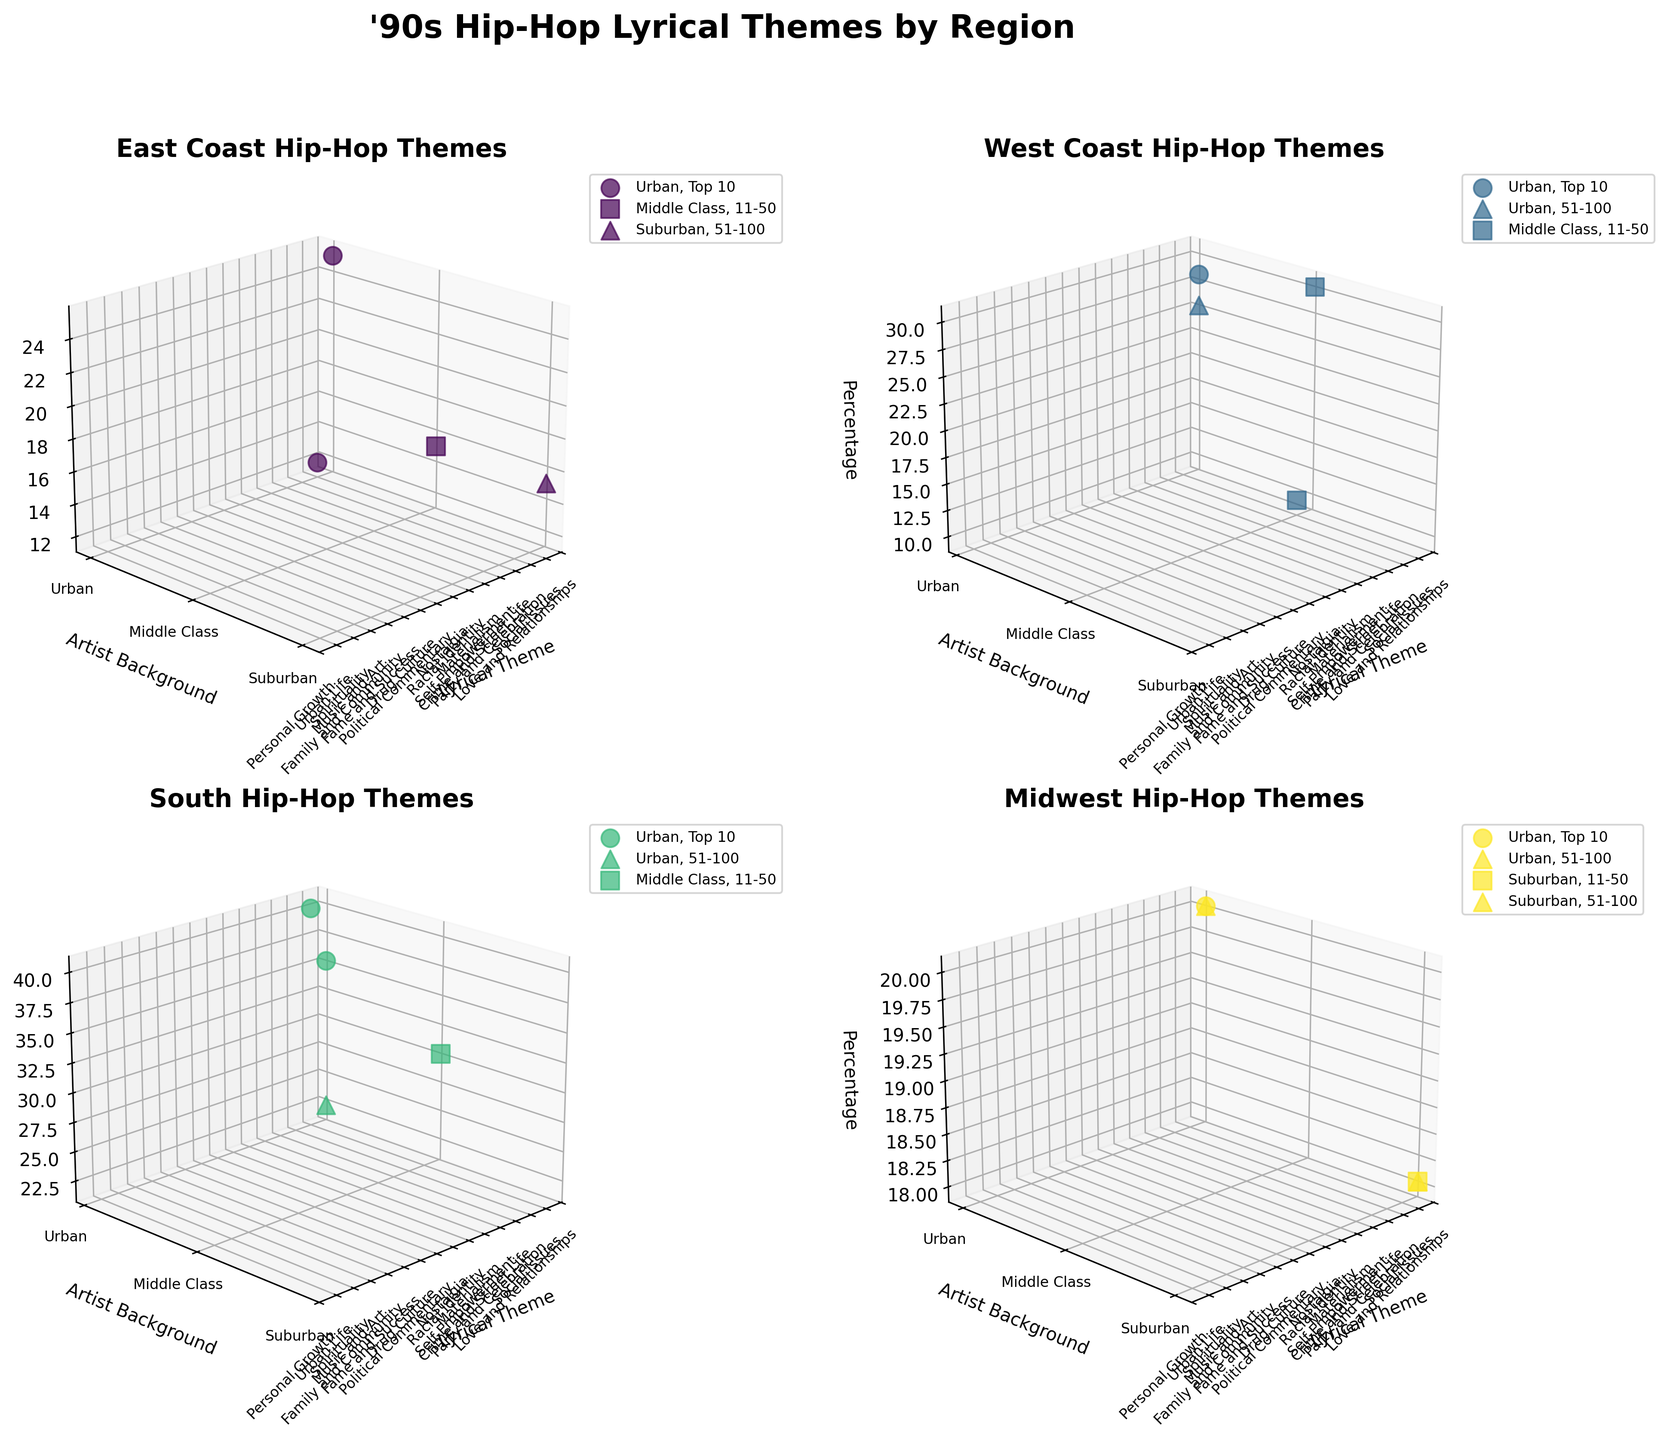What is the title of the figure? The title of the figure is displayed at the top and describes the overarching theme of the plot.
Answer: '90s Hip-Hop Lyrical Themes by Region Which region has a subplot highlighting "Political Commentary" as a lyrical theme? By observing each subplot, which represents a different region, we can identify the presence of "Political Commentary" in the subplot for the East Coast.
Answer: East Coast How does the distribution of "Drug Culture" differ between chart positions on the West Coast? In the West Coast subplot, "Drug Culture" is marked with different markers. The "Top 10" position is scarce, while the "51-100" position shows notable representation.
Answer: More prominent in "51-100" than "Top 10" Which lyrical theme is represented by the highest percentage in the South region for Top 10 chart position? Observing the South subplot and specifically focusing on the Top 10 positions, the vertical axis shows "Urban Life" with the highest percentage.
Answer: Urban Life Compare the lyrical themes of "Self-Empowerment" and "Materialism" by their percentages in urban backgrounds on the East Coast. The East Coast subplot shows "Self-Empowerment" at 15%, whereas "Materialism" is not present in the urban background, hence can't be shown in comparison.
Answer: "Self-Empowerment" is 15%; "Materialism" not present In the Midwest region, what is the lyrical theme with the lowest percentage for suburban artists? Observing the Midwest subplot, focusing on suburban artists, "Personal Growth" and "Nostalgia" have 18% each, with no theme lower than these percentages.
Answer: Personal Growth and Nostalgia Which region has the most diverse representation of lyrical themes in the data? The regions with their subplots indicate this visually. The East Coast with multiple diverse colors and markers shows more themes compared to others.
Answer: East Coast Identify the background that dominates the "Social Issues" theme in the West Coast region. By examining the West Coast subplot specifically for "Social Issues" and checking the background types, the marker shows the Middle Class background.
Answer: Middle Class What's the common lyrical theme between the East Coast and Midwest regions in Urban artists for Top 10 chart positions? Looking at both subplots simultaneously, the common lyrical theme on the vertical axis in Urban artists and Top 10 is represented by "Family and Community" in Midwest but it is not represented in East Coast for the same category.
Answer: None 